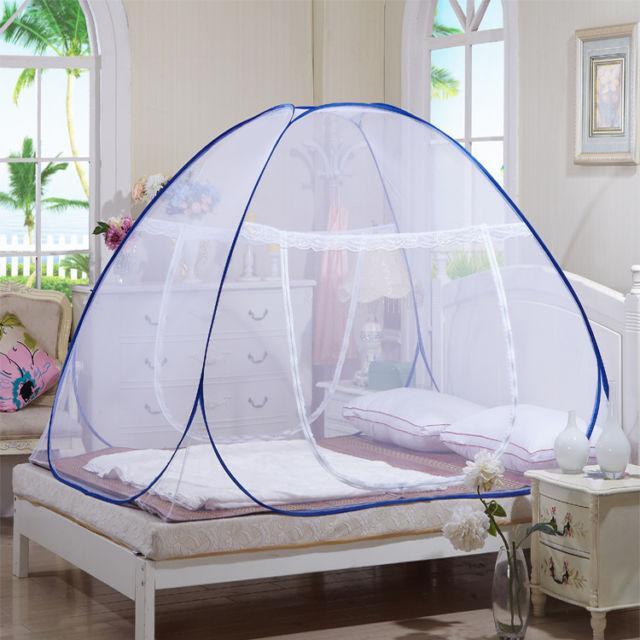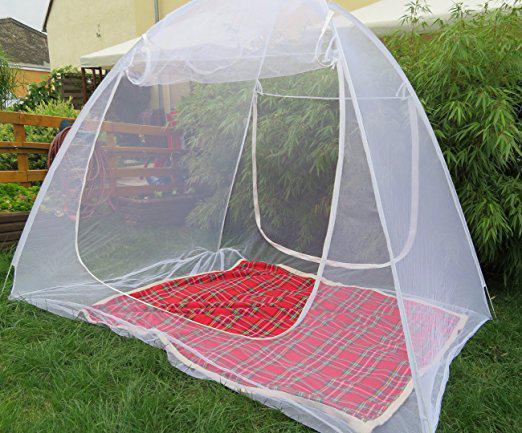The first image is the image on the left, the second image is the image on the right. Assess this claim about the two images: "there are two white pillows in the image on the left". Correct or not? Answer yes or no. Yes. 